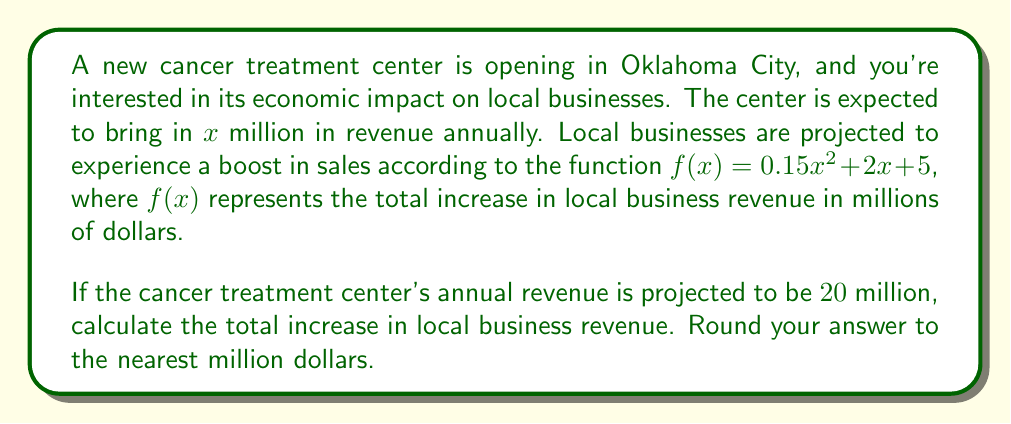Teach me how to tackle this problem. To solve this problem, we need to follow these steps:

1. Identify the given function: $f(x) = 0.15x^2 + 2x + 5$
2. Substitute the given value of $x = 20$ into the function
3. Calculate the result
4. Round to the nearest million dollars

Let's proceed step by step:

1. The function is already given: $f(x) = 0.15x^2 + 2x + 5$

2. Substitute $x = 20$ into the function:
   $f(20) = 0.15(20)^2 + 2(20) + 5$

3. Calculate:
   $f(20) = 0.15(400) + 40 + 5$
   $f(20) = 60 + 40 + 5$
   $f(20) = 105$

4. The result is already in millions, so we just need to round to the nearest million:
   $105$ million dollars

Therefore, the total increase in local business revenue is expected to be $105 million.
Answer: $105 million 